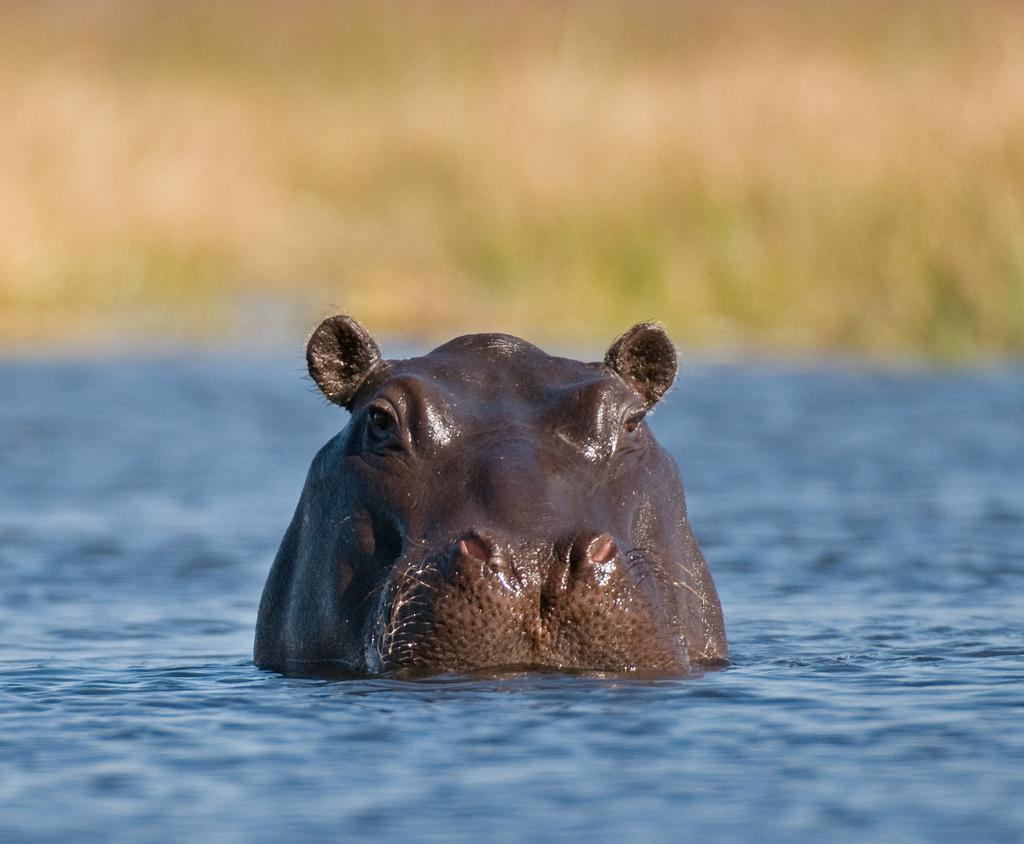What is the main subject of the image? There is an animal in the water. Can you describe the background of the image? The background of the image is blurred. What type of grass can be seen growing on the level in the image? There is no grass or level present in the image; it features an animal in the water with a blurred background. 